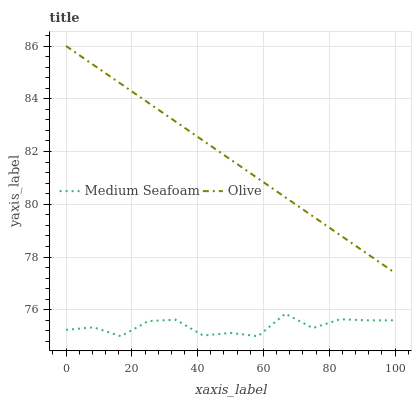Does Medium Seafoam have the minimum area under the curve?
Answer yes or no. Yes. Does Olive have the maximum area under the curve?
Answer yes or no. Yes. Does Medium Seafoam have the maximum area under the curve?
Answer yes or no. No. Is Olive the smoothest?
Answer yes or no. Yes. Is Medium Seafoam the roughest?
Answer yes or no. Yes. Is Medium Seafoam the smoothest?
Answer yes or no. No. Does Medium Seafoam have the lowest value?
Answer yes or no. Yes. Does Olive have the highest value?
Answer yes or no. Yes. Does Medium Seafoam have the highest value?
Answer yes or no. No. Is Medium Seafoam less than Olive?
Answer yes or no. Yes. Is Olive greater than Medium Seafoam?
Answer yes or no. Yes. Does Medium Seafoam intersect Olive?
Answer yes or no. No. 